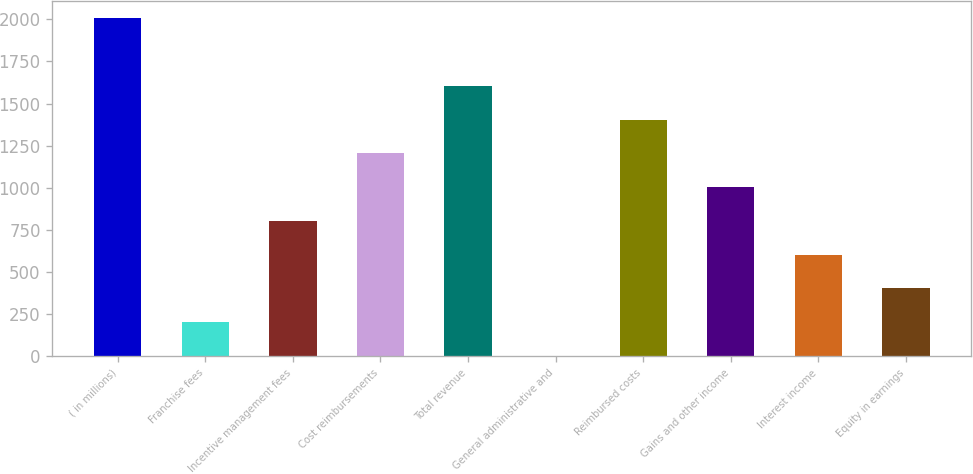<chart> <loc_0><loc_0><loc_500><loc_500><bar_chart><fcel>( in millions)<fcel>Franchise fees<fcel>Incentive management fees<fcel>Cost reimbursements<fcel>Total revenue<fcel>General administrative and<fcel>Reimbursed costs<fcel>Gains and other income<fcel>Interest income<fcel>Equity in earnings<nl><fcel>2006<fcel>201.5<fcel>803<fcel>1204<fcel>1605<fcel>1<fcel>1404.5<fcel>1003.5<fcel>602.5<fcel>402<nl></chart> 